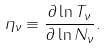Convert formula to latex. <formula><loc_0><loc_0><loc_500><loc_500>\eta _ { \nu } \equiv \frac { \partial \ln T _ { \nu } } { \partial \ln N _ { \nu } } .</formula> 